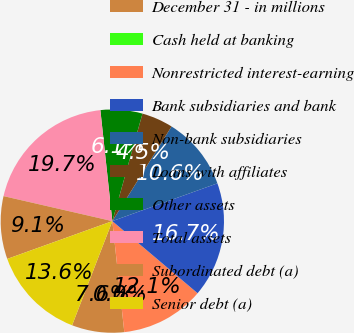Convert chart. <chart><loc_0><loc_0><loc_500><loc_500><pie_chart><fcel>December 31 - in millions<fcel>Cash held at banking<fcel>Nonrestricted interest-earning<fcel>Bank subsidiaries and bank<fcel>Non-bank subsidiaries<fcel>Loans with affiliates<fcel>Other assets<fcel>Total assets<fcel>Subordinated debt (a)<fcel>Senior debt (a)<nl><fcel>7.58%<fcel>0.0%<fcel>12.12%<fcel>16.67%<fcel>10.61%<fcel>4.55%<fcel>6.06%<fcel>19.7%<fcel>9.09%<fcel>13.64%<nl></chart> 